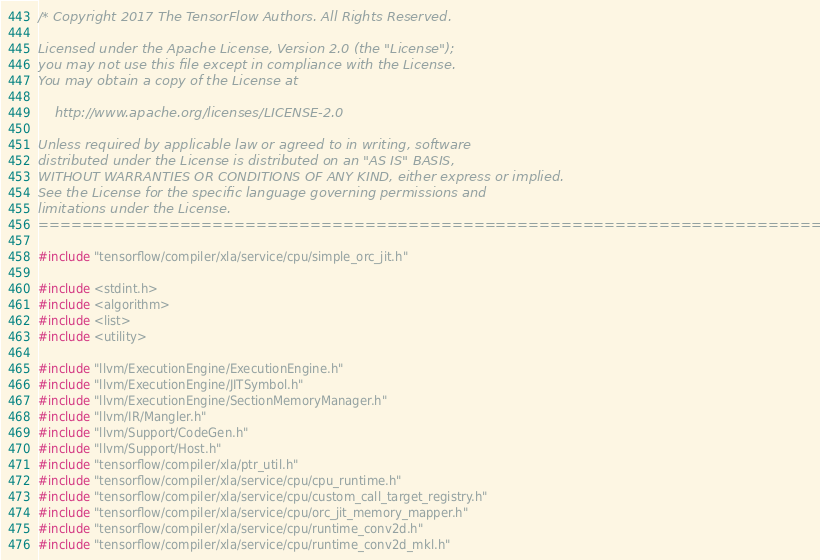Convert code to text. <code><loc_0><loc_0><loc_500><loc_500><_C++_>/* Copyright 2017 The TensorFlow Authors. All Rights Reserved.

Licensed under the Apache License, Version 2.0 (the "License");
you may not use this file except in compliance with the License.
You may obtain a copy of the License at

    http://www.apache.org/licenses/LICENSE-2.0

Unless required by applicable law or agreed to in writing, software
distributed under the License is distributed on an "AS IS" BASIS,
WITHOUT WARRANTIES OR CONDITIONS OF ANY KIND, either express or implied.
See the License for the specific language governing permissions and
limitations under the License.
==============================================================================*/

#include "tensorflow/compiler/xla/service/cpu/simple_orc_jit.h"

#include <stdint.h>
#include <algorithm>
#include <list>
#include <utility>

#include "llvm/ExecutionEngine/ExecutionEngine.h"
#include "llvm/ExecutionEngine/JITSymbol.h"
#include "llvm/ExecutionEngine/SectionMemoryManager.h"
#include "llvm/IR/Mangler.h"
#include "llvm/Support/CodeGen.h"
#include "llvm/Support/Host.h"
#include "tensorflow/compiler/xla/ptr_util.h"
#include "tensorflow/compiler/xla/service/cpu/cpu_runtime.h"
#include "tensorflow/compiler/xla/service/cpu/custom_call_target_registry.h"
#include "tensorflow/compiler/xla/service/cpu/orc_jit_memory_mapper.h"
#include "tensorflow/compiler/xla/service/cpu/runtime_conv2d.h"
#include "tensorflow/compiler/xla/service/cpu/runtime_conv2d_mkl.h"</code> 